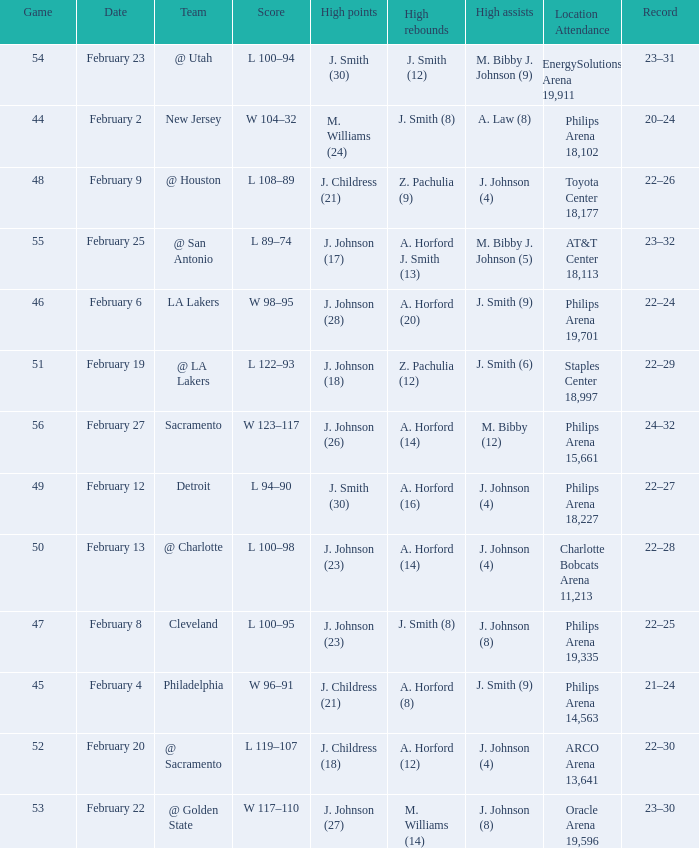What is the team located at philips arena 18,227? Detroit. 